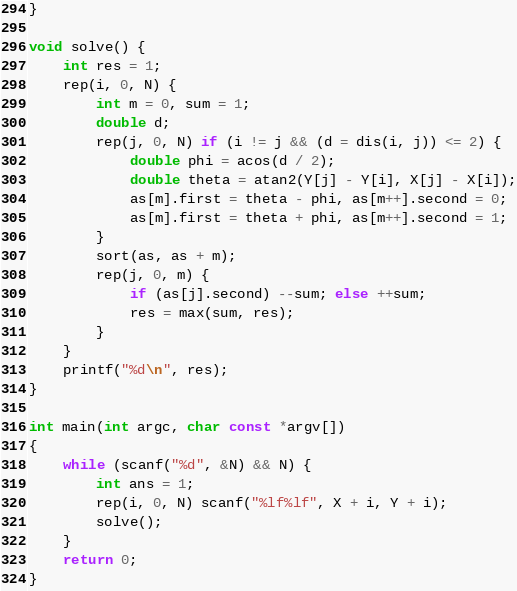<code> <loc_0><loc_0><loc_500><loc_500><_C++_>}

void solve() {
    int res = 1;
    rep(i, 0, N) {
        int m = 0, sum = 1;
        double d;
        rep(j, 0, N) if (i != j && (d = dis(i, j)) <= 2) {
            double phi = acos(d / 2);
            double theta = atan2(Y[j] - Y[i], X[j] - X[i]);
            as[m].first = theta - phi, as[m++].second = 0;
            as[m].first = theta + phi, as[m++].second = 1;
        }
        sort(as, as + m);
        rep(j, 0, m) {
            if (as[j].second) --sum; else ++sum;
            res = max(sum, res);
        }
    }
    printf("%d\n", res);
}

int main(int argc, char const *argv[])
{
    while (scanf("%d", &N) && N) {
        int ans = 1;
        rep(i, 0, N) scanf("%lf%lf", X + i, Y + i);
        solve();
    }    
    return 0;
}</code> 